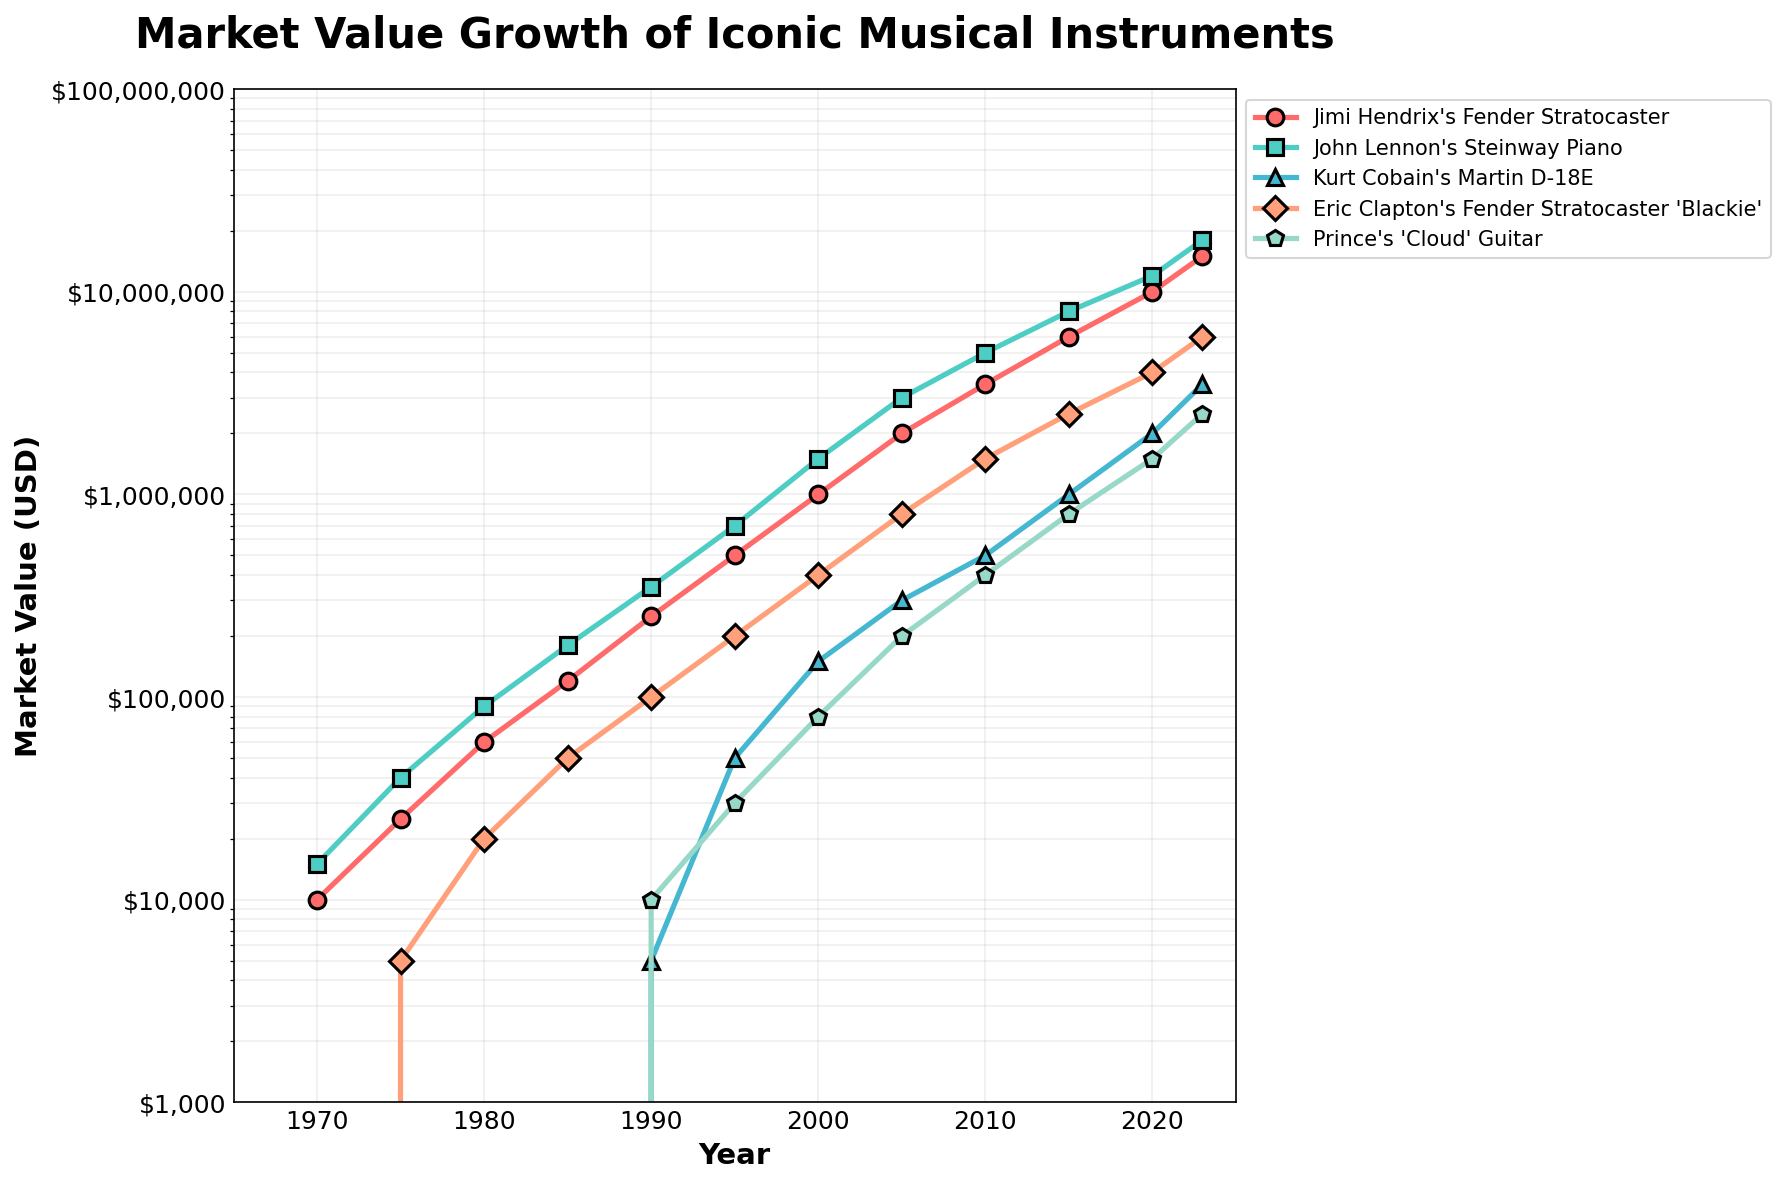What's the market value trend for John Lennon's Steinway Piano? To analyze the trend, observe the line associated with John Lennon's Steinway Piano from 1970 to 2023. It starts at $15,000 in 1970, gradually increases across the years, and reaches $18,000,000 by 2023. This shows a consistent upward trend in market value over time.
Answer: Consistent upward trend Which musical instrument had the highest market value by 2023? Compare the end values of the lines for all the musical instruments in 2023. John Lennon's Steinway Piano reaches $18,000,000, which is the highest among all listed instruments.
Answer: John Lennon's Steinway Piano What was the market value difference between Prince's 'Cloud' Guitar and Kurt Cobain's Martin D-18E in 2020? Find the market values of both instruments in 2020. Prince's 'Cloud' Guitar is at $1,500,000, and Kurt Cobain's Martin D-18E is at $2,000,000. Subtract the value of Prince's 'Cloud' Guitar from Kurt Cobain's Martin D-18E: $2,000,000 - $1,500,000 = $500,000.
Answer: $500,000 Which instrument experienced the fastest value growth between 2000 and 2005? Compare the increase in market values for each instrument from 2000 to 2005. The market value of John Lennon's Steinway Piano increases from $1,500,000 to $3,000,000, which is a growth of $1,500,000. This is higher compared to other instruments in the same period.
Answer: John Lennon's Steinway Piano What is the average market value of Jimi Hendrix's Fender Stratocaster in 1990 and 1995? Find the market values of Jimi Hendrix's Fender Stratocaster in 1990 and 1995. They are $250,000 in 1990 and $500,000 in 1995. Add these values and divide by 2 to find the average: ($250,000 + $500,000) / 2 = $375,000.
Answer: $375,000 How did the market value of Eric Clapton's Fender Stratocaster 'Blackie' compare to Jimi Hendrix's Fender Stratocaster in 2010? Look at the values in 2010: Eric Clapton's Fender Stratocaster 'Blackie' is valued at $1,500,000, while Jimi Hendrix's Fender Stratocaster is at $3,500,000. Jimi Hendrix's guitar has a higher market value.
Answer: Jimi Hendrix's Fender Stratocaster What color represents Prince's 'Cloud' Guitar? Identify the color of the line on the chart that corresponds to Prince's 'Cloud' Guitar. The line is green.
Answer: Green Calculate the total market value for all instruments in 1985. Add the values of all instruments in 1985: Jimi Hendrix's Fender Stratocaster ($120,000), John Lennon's Steinway Piano ($180,000), Eric Clapton's Fender Stratocaster 'Blackie' ($50,000), => Total: $120,000 + $180,000 + $0 + $50,000 = $350,000.
Answer: $350,000 